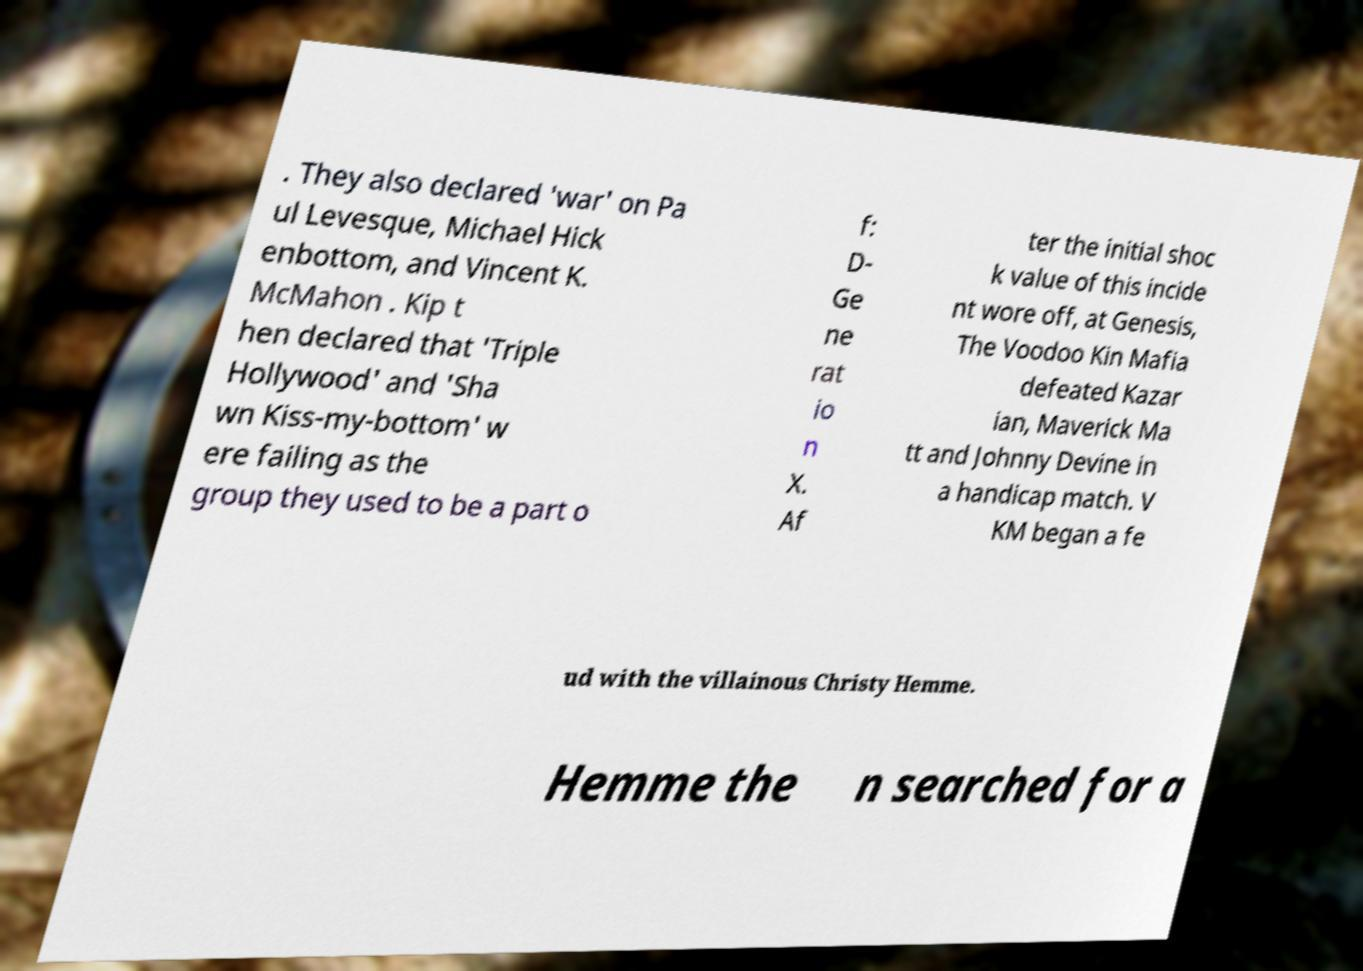Can you read and provide the text displayed in the image?This photo seems to have some interesting text. Can you extract and type it out for me? . They also declared 'war' on Pa ul Levesque, Michael Hick enbottom, and Vincent K. McMahon . Kip t hen declared that 'Triple Hollywood' and 'Sha wn Kiss-my-bottom' w ere failing as the group they used to be a part o f: D- Ge ne rat io n X. Af ter the initial shoc k value of this incide nt wore off, at Genesis, The Voodoo Kin Mafia defeated Kazar ian, Maverick Ma tt and Johnny Devine in a handicap match. V KM began a fe ud with the villainous Christy Hemme. Hemme the n searched for a 